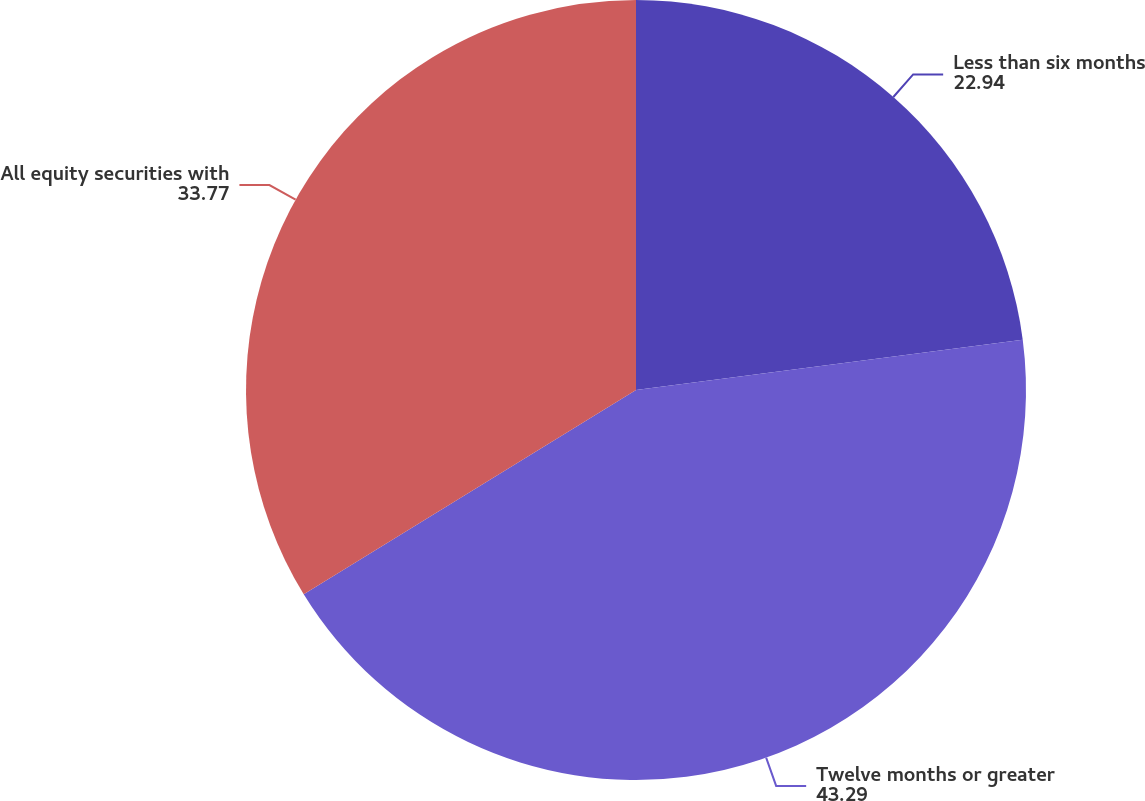Convert chart to OTSL. <chart><loc_0><loc_0><loc_500><loc_500><pie_chart><fcel>Less than six months<fcel>Twelve months or greater<fcel>All equity securities with<nl><fcel>22.94%<fcel>43.29%<fcel>33.77%<nl></chart> 